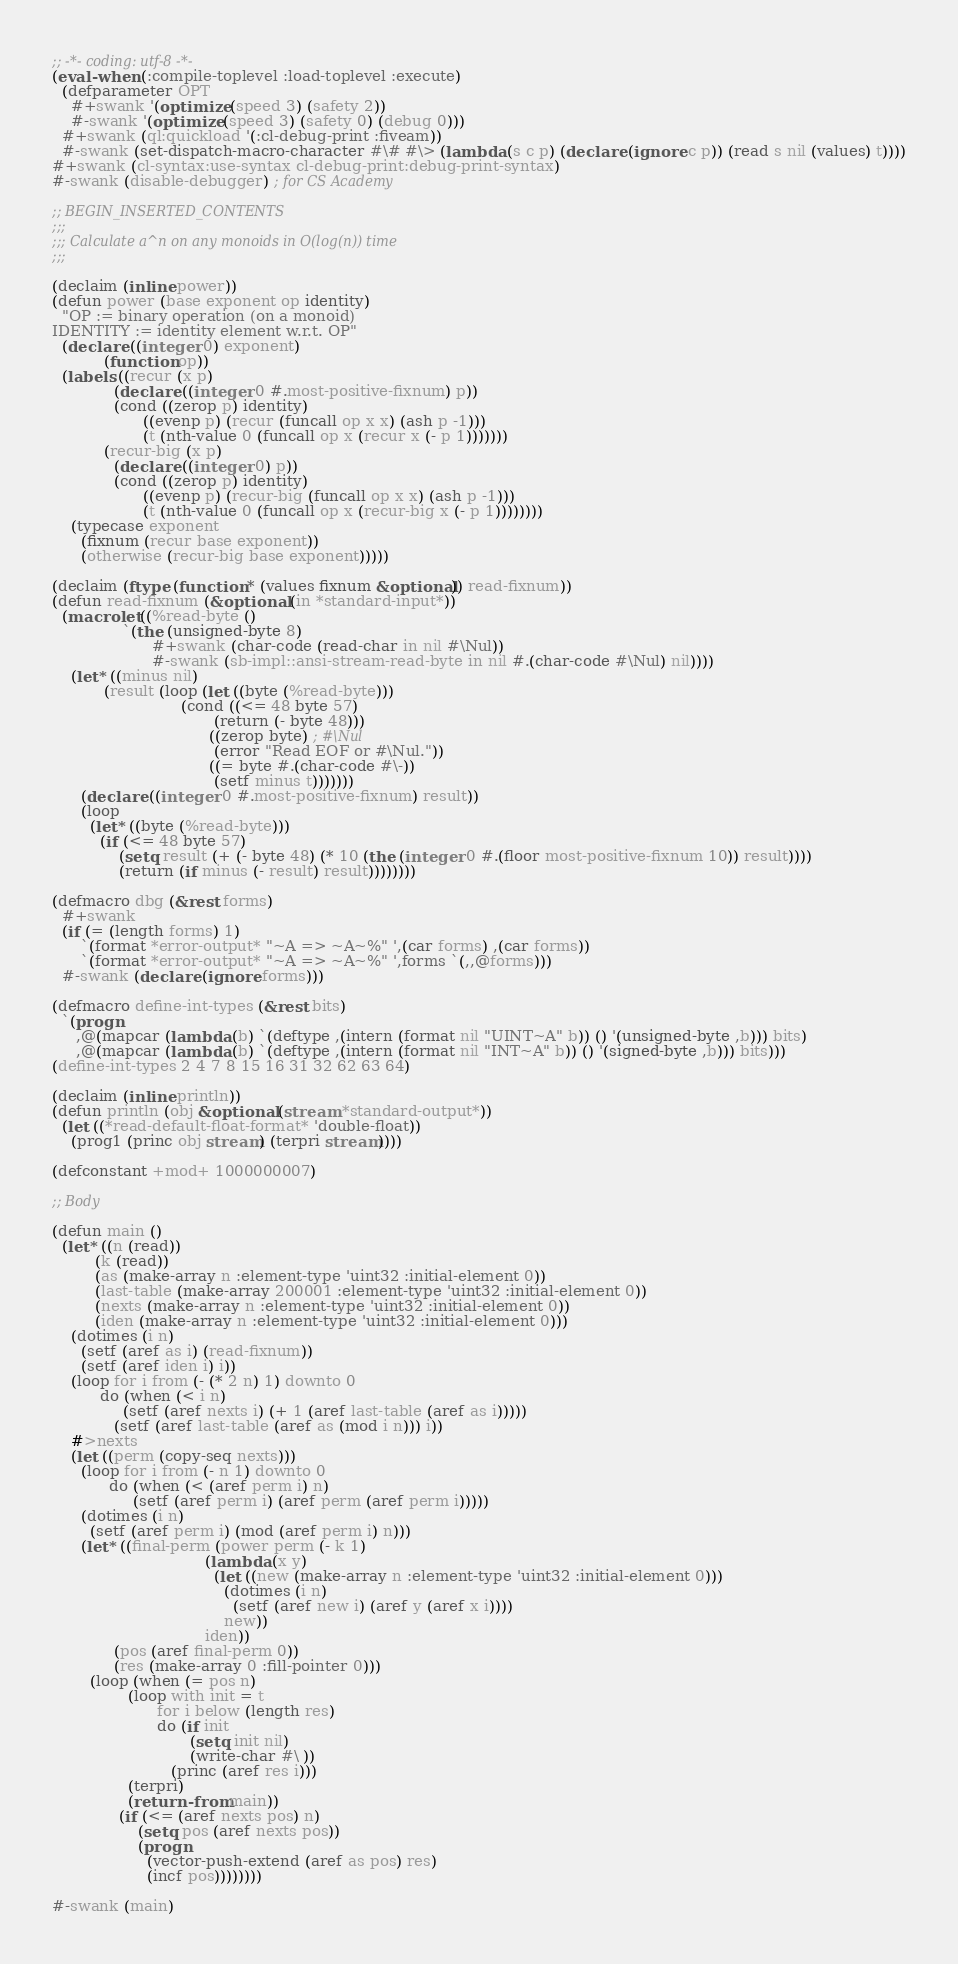Convert code to text. <code><loc_0><loc_0><loc_500><loc_500><_Lisp_>;; -*- coding: utf-8 -*-
(eval-when (:compile-toplevel :load-toplevel :execute)
  (defparameter OPT
    #+swank '(optimize (speed 3) (safety 2))
    #-swank '(optimize (speed 3) (safety 0) (debug 0)))
  #+swank (ql:quickload '(:cl-debug-print :fiveam))
  #-swank (set-dispatch-macro-character #\# #\> (lambda (s c p) (declare (ignore c p)) (read s nil (values) t))))
#+swank (cl-syntax:use-syntax cl-debug-print:debug-print-syntax)
#-swank (disable-debugger) ; for CS Academy

;; BEGIN_INSERTED_CONTENTS
;;;
;;; Calculate a^n on any monoids in O(log(n)) time
;;;

(declaim (inline power))
(defun power (base exponent op identity)
  "OP := binary operation (on a monoid)
IDENTITY := identity element w.r.t. OP"
  (declare ((integer 0) exponent)
           (function op))
  (labels ((recur (x p)
             (declare ((integer 0 #.most-positive-fixnum) p))
             (cond ((zerop p) identity)
                   ((evenp p) (recur (funcall op x x) (ash p -1)))
                   (t (nth-value 0 (funcall op x (recur x (- p 1)))))))
           (recur-big (x p)
             (declare ((integer 0) p))
             (cond ((zerop p) identity)
                   ((evenp p) (recur-big (funcall op x x) (ash p -1)))
                   (t (nth-value 0 (funcall op x (recur-big x (- p 1))))))))
    (typecase exponent
      (fixnum (recur base exponent))
      (otherwise (recur-big base exponent)))))

(declaim (ftype (function * (values fixnum &optional)) read-fixnum))
(defun read-fixnum (&optional (in *standard-input*))
  (macrolet ((%read-byte ()
               `(the (unsigned-byte 8)
                     #+swank (char-code (read-char in nil #\Nul))
                     #-swank (sb-impl::ansi-stream-read-byte in nil #.(char-code #\Nul) nil))))
    (let* ((minus nil)
           (result (loop (let ((byte (%read-byte)))
                           (cond ((<= 48 byte 57)
                                  (return (- byte 48)))
                                 ((zerop byte) ; #\Nul
                                  (error "Read EOF or #\Nul."))
                                 ((= byte #.(char-code #\-))
                                  (setf minus t)))))))
      (declare ((integer 0 #.most-positive-fixnum) result))
      (loop
        (let* ((byte (%read-byte)))
          (if (<= 48 byte 57)
              (setq result (+ (- byte 48) (* 10 (the (integer 0 #.(floor most-positive-fixnum 10)) result))))
              (return (if minus (- result) result))))))))

(defmacro dbg (&rest forms)
  #+swank
  (if (= (length forms) 1)
      `(format *error-output* "~A => ~A~%" ',(car forms) ,(car forms))
      `(format *error-output* "~A => ~A~%" ',forms `(,,@forms)))
  #-swank (declare (ignore forms)))

(defmacro define-int-types (&rest bits)
  `(progn
     ,@(mapcar (lambda (b) `(deftype ,(intern (format nil "UINT~A" b)) () '(unsigned-byte ,b))) bits)
     ,@(mapcar (lambda (b) `(deftype ,(intern (format nil "INT~A" b)) () '(signed-byte ,b))) bits)))
(define-int-types 2 4 7 8 15 16 31 32 62 63 64)

(declaim (inline println))
(defun println (obj &optional (stream *standard-output*))
  (let ((*read-default-float-format* 'double-float))
    (prog1 (princ obj stream) (terpri stream))))

(defconstant +mod+ 1000000007)

;; Body

(defun main ()
  (let* ((n (read))
         (k (read))
         (as (make-array n :element-type 'uint32 :initial-element 0))
         (last-table (make-array 200001 :element-type 'uint32 :initial-element 0))
         (nexts (make-array n :element-type 'uint32 :initial-element 0))
         (iden (make-array n :element-type 'uint32 :initial-element 0)))
    (dotimes (i n)
      (setf (aref as i) (read-fixnum))
      (setf (aref iden i) i))
    (loop for i from (- (* 2 n) 1) downto 0
          do (when (< i n)
               (setf (aref nexts i) (+ 1 (aref last-table (aref as i)))))
             (setf (aref last-table (aref as (mod i n))) i))
    #>nexts
    (let ((perm (copy-seq nexts)))
      (loop for i from (- n 1) downto 0
            do (when (< (aref perm i) n)
                 (setf (aref perm i) (aref perm (aref perm i)))))
      (dotimes (i n)
        (setf (aref perm i) (mod (aref perm i) n)))
      (let* ((final-perm (power perm (- k 1)
                                (lambda (x y)
                                  (let ((new (make-array n :element-type 'uint32 :initial-element 0)))
                                    (dotimes (i n)
                                      (setf (aref new i) (aref y (aref x i))))
                                    new))
                                iden))
             (pos (aref final-perm 0))
             (res (make-array 0 :fill-pointer 0)))
        (loop (when (= pos n)
                (loop with init = t
                      for i below (length res)
                      do (if init
                             (setq init nil)
                             (write-char #\ ))
                         (princ (aref res i)))
                (terpri)
                (return-from main))
              (if (<= (aref nexts pos) n)
                  (setq pos (aref nexts pos))
                  (progn
                    (vector-push-extend (aref as pos) res)
                    (incf pos))))))))

#-swank (main)
</code> 